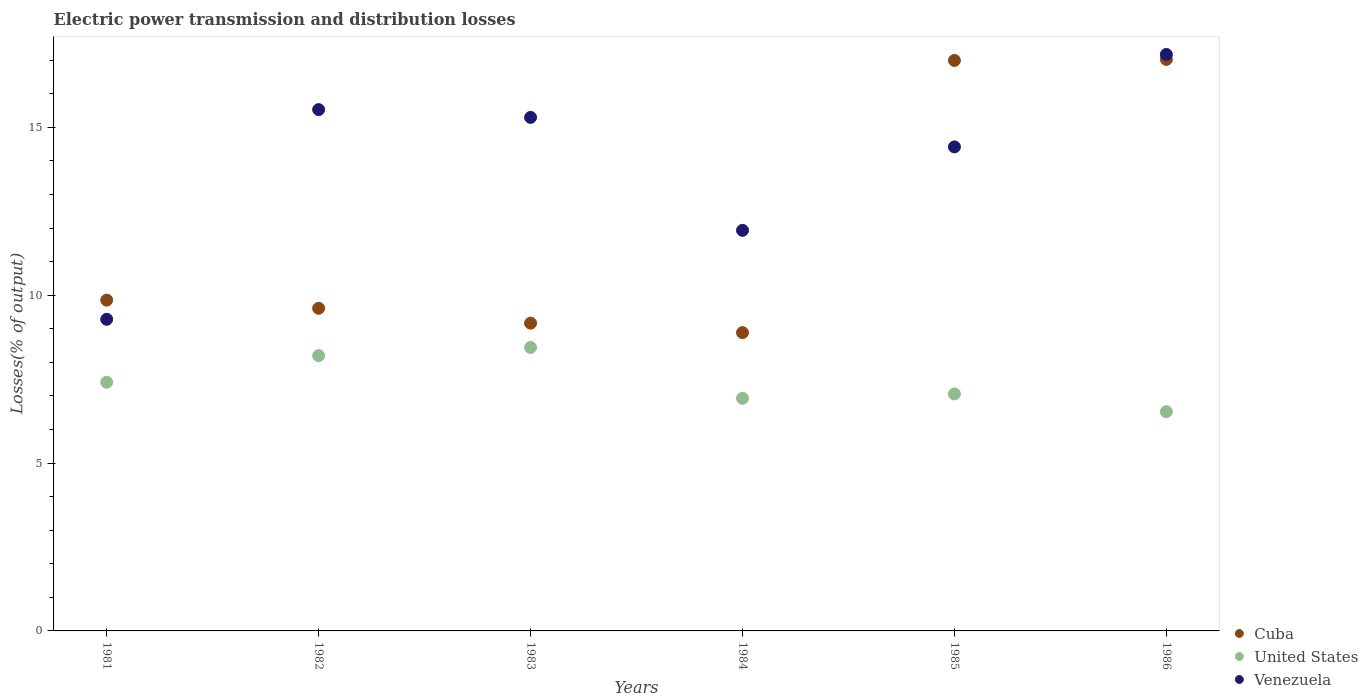How many different coloured dotlines are there?
Give a very brief answer. 3. Is the number of dotlines equal to the number of legend labels?
Give a very brief answer. Yes. What is the electric power transmission and distribution losses in Cuba in 1986?
Offer a terse response. 17.02. Across all years, what is the maximum electric power transmission and distribution losses in United States?
Your answer should be very brief. 8.44. Across all years, what is the minimum electric power transmission and distribution losses in Venezuela?
Your response must be concise. 9.28. In which year was the electric power transmission and distribution losses in Venezuela maximum?
Provide a succinct answer. 1986. In which year was the electric power transmission and distribution losses in Cuba minimum?
Keep it short and to the point. 1984. What is the total electric power transmission and distribution losses in Venezuela in the graph?
Give a very brief answer. 83.63. What is the difference between the electric power transmission and distribution losses in Venezuela in 1984 and that in 1986?
Give a very brief answer. -5.24. What is the difference between the electric power transmission and distribution losses in United States in 1985 and the electric power transmission and distribution losses in Venezuela in 1984?
Offer a very short reply. -4.87. What is the average electric power transmission and distribution losses in Cuba per year?
Make the answer very short. 11.92. In the year 1984, what is the difference between the electric power transmission and distribution losses in Cuba and electric power transmission and distribution losses in Venezuela?
Your answer should be very brief. -3.05. What is the ratio of the electric power transmission and distribution losses in Cuba in 1983 to that in 1984?
Your response must be concise. 1.03. Is the electric power transmission and distribution losses in Venezuela in 1983 less than that in 1986?
Offer a terse response. Yes. Is the difference between the electric power transmission and distribution losses in Cuba in 1981 and 1982 greater than the difference between the electric power transmission and distribution losses in Venezuela in 1981 and 1982?
Ensure brevity in your answer.  Yes. What is the difference between the highest and the second highest electric power transmission and distribution losses in United States?
Offer a terse response. 0.24. What is the difference between the highest and the lowest electric power transmission and distribution losses in Venezuela?
Offer a terse response. 7.89. Is the sum of the electric power transmission and distribution losses in Cuba in 1984 and 1986 greater than the maximum electric power transmission and distribution losses in United States across all years?
Ensure brevity in your answer.  Yes. Does the electric power transmission and distribution losses in Cuba monotonically increase over the years?
Your answer should be very brief. No. Is the electric power transmission and distribution losses in United States strictly greater than the electric power transmission and distribution losses in Venezuela over the years?
Provide a succinct answer. No. Is the electric power transmission and distribution losses in United States strictly less than the electric power transmission and distribution losses in Venezuela over the years?
Make the answer very short. Yes. How many dotlines are there?
Your answer should be very brief. 3. Does the graph contain grids?
Your answer should be very brief. No. Where does the legend appear in the graph?
Keep it short and to the point. Bottom right. What is the title of the graph?
Provide a short and direct response. Electric power transmission and distribution losses. Does "Arab World" appear as one of the legend labels in the graph?
Offer a terse response. No. What is the label or title of the Y-axis?
Give a very brief answer. Losses(% of output). What is the Losses(% of output) in Cuba in 1981?
Keep it short and to the point. 9.85. What is the Losses(% of output) of United States in 1981?
Give a very brief answer. 7.41. What is the Losses(% of output) of Venezuela in 1981?
Ensure brevity in your answer.  9.28. What is the Losses(% of output) of Cuba in 1982?
Give a very brief answer. 9.61. What is the Losses(% of output) in United States in 1982?
Your response must be concise. 8.2. What is the Losses(% of output) of Venezuela in 1982?
Offer a terse response. 15.53. What is the Losses(% of output) of Cuba in 1983?
Make the answer very short. 9.17. What is the Losses(% of output) in United States in 1983?
Offer a very short reply. 8.44. What is the Losses(% of output) of Venezuela in 1983?
Offer a very short reply. 15.3. What is the Losses(% of output) in Cuba in 1984?
Provide a succinct answer. 8.88. What is the Losses(% of output) in United States in 1984?
Your response must be concise. 6.93. What is the Losses(% of output) of Venezuela in 1984?
Provide a short and direct response. 11.93. What is the Losses(% of output) in Cuba in 1985?
Offer a terse response. 16.99. What is the Losses(% of output) in United States in 1985?
Offer a terse response. 7.06. What is the Losses(% of output) in Venezuela in 1985?
Offer a very short reply. 14.42. What is the Losses(% of output) of Cuba in 1986?
Keep it short and to the point. 17.02. What is the Losses(% of output) in United States in 1986?
Keep it short and to the point. 6.53. What is the Losses(% of output) of Venezuela in 1986?
Provide a succinct answer. 17.17. Across all years, what is the maximum Losses(% of output) in Cuba?
Make the answer very short. 17.02. Across all years, what is the maximum Losses(% of output) in United States?
Make the answer very short. 8.44. Across all years, what is the maximum Losses(% of output) of Venezuela?
Keep it short and to the point. 17.17. Across all years, what is the minimum Losses(% of output) in Cuba?
Your answer should be very brief. 8.88. Across all years, what is the minimum Losses(% of output) of United States?
Provide a short and direct response. 6.53. Across all years, what is the minimum Losses(% of output) in Venezuela?
Your response must be concise. 9.28. What is the total Losses(% of output) of Cuba in the graph?
Keep it short and to the point. 71.53. What is the total Losses(% of output) of United States in the graph?
Provide a short and direct response. 44.57. What is the total Losses(% of output) of Venezuela in the graph?
Keep it short and to the point. 83.63. What is the difference between the Losses(% of output) in Cuba in 1981 and that in 1982?
Your answer should be compact. 0.24. What is the difference between the Losses(% of output) in United States in 1981 and that in 1982?
Offer a very short reply. -0.79. What is the difference between the Losses(% of output) in Venezuela in 1981 and that in 1982?
Offer a terse response. -6.25. What is the difference between the Losses(% of output) of Cuba in 1981 and that in 1983?
Make the answer very short. 0.69. What is the difference between the Losses(% of output) of United States in 1981 and that in 1983?
Your answer should be very brief. -1.04. What is the difference between the Losses(% of output) of Venezuela in 1981 and that in 1983?
Your answer should be compact. -6.01. What is the difference between the Losses(% of output) in Cuba in 1981 and that in 1984?
Give a very brief answer. 0.97. What is the difference between the Losses(% of output) of United States in 1981 and that in 1984?
Your response must be concise. 0.48. What is the difference between the Losses(% of output) of Venezuela in 1981 and that in 1984?
Provide a succinct answer. -2.65. What is the difference between the Losses(% of output) of Cuba in 1981 and that in 1985?
Make the answer very short. -7.14. What is the difference between the Losses(% of output) in United States in 1981 and that in 1985?
Your answer should be very brief. 0.35. What is the difference between the Losses(% of output) in Venezuela in 1981 and that in 1985?
Your answer should be compact. -5.13. What is the difference between the Losses(% of output) in Cuba in 1981 and that in 1986?
Make the answer very short. -7.17. What is the difference between the Losses(% of output) of United States in 1981 and that in 1986?
Your answer should be compact. 0.88. What is the difference between the Losses(% of output) in Venezuela in 1981 and that in 1986?
Give a very brief answer. -7.89. What is the difference between the Losses(% of output) of Cuba in 1982 and that in 1983?
Give a very brief answer. 0.44. What is the difference between the Losses(% of output) in United States in 1982 and that in 1983?
Give a very brief answer. -0.24. What is the difference between the Losses(% of output) of Venezuela in 1982 and that in 1983?
Make the answer very short. 0.23. What is the difference between the Losses(% of output) of Cuba in 1982 and that in 1984?
Offer a terse response. 0.73. What is the difference between the Losses(% of output) of United States in 1982 and that in 1984?
Your answer should be compact. 1.27. What is the difference between the Losses(% of output) of Venezuela in 1982 and that in 1984?
Ensure brevity in your answer.  3.6. What is the difference between the Losses(% of output) of Cuba in 1982 and that in 1985?
Make the answer very short. -7.38. What is the difference between the Losses(% of output) of United States in 1982 and that in 1985?
Your answer should be very brief. 1.14. What is the difference between the Losses(% of output) of Venezuela in 1982 and that in 1985?
Offer a very short reply. 1.11. What is the difference between the Losses(% of output) in Cuba in 1982 and that in 1986?
Offer a very short reply. -7.41. What is the difference between the Losses(% of output) of United States in 1982 and that in 1986?
Keep it short and to the point. 1.67. What is the difference between the Losses(% of output) in Venezuela in 1982 and that in 1986?
Ensure brevity in your answer.  -1.64. What is the difference between the Losses(% of output) in Cuba in 1983 and that in 1984?
Provide a short and direct response. 0.28. What is the difference between the Losses(% of output) in United States in 1983 and that in 1984?
Your response must be concise. 1.51. What is the difference between the Losses(% of output) of Venezuela in 1983 and that in 1984?
Offer a terse response. 3.36. What is the difference between the Losses(% of output) in Cuba in 1983 and that in 1985?
Offer a very short reply. -7.83. What is the difference between the Losses(% of output) in United States in 1983 and that in 1985?
Provide a short and direct response. 1.38. What is the difference between the Losses(% of output) of Venezuela in 1983 and that in 1985?
Keep it short and to the point. 0.88. What is the difference between the Losses(% of output) in Cuba in 1983 and that in 1986?
Give a very brief answer. -7.86. What is the difference between the Losses(% of output) of United States in 1983 and that in 1986?
Make the answer very short. 1.91. What is the difference between the Losses(% of output) of Venezuela in 1983 and that in 1986?
Ensure brevity in your answer.  -1.87. What is the difference between the Losses(% of output) of Cuba in 1984 and that in 1985?
Make the answer very short. -8.11. What is the difference between the Losses(% of output) in United States in 1984 and that in 1985?
Provide a succinct answer. -0.13. What is the difference between the Losses(% of output) of Venezuela in 1984 and that in 1985?
Your answer should be compact. -2.49. What is the difference between the Losses(% of output) of Cuba in 1984 and that in 1986?
Ensure brevity in your answer.  -8.14. What is the difference between the Losses(% of output) in United States in 1984 and that in 1986?
Keep it short and to the point. 0.4. What is the difference between the Losses(% of output) in Venezuela in 1984 and that in 1986?
Provide a short and direct response. -5.24. What is the difference between the Losses(% of output) of Cuba in 1985 and that in 1986?
Your response must be concise. -0.03. What is the difference between the Losses(% of output) of United States in 1985 and that in 1986?
Provide a succinct answer. 0.53. What is the difference between the Losses(% of output) in Venezuela in 1985 and that in 1986?
Offer a terse response. -2.75. What is the difference between the Losses(% of output) of Cuba in 1981 and the Losses(% of output) of United States in 1982?
Provide a succinct answer. 1.66. What is the difference between the Losses(% of output) of Cuba in 1981 and the Losses(% of output) of Venezuela in 1982?
Provide a short and direct response. -5.67. What is the difference between the Losses(% of output) of United States in 1981 and the Losses(% of output) of Venezuela in 1982?
Provide a succinct answer. -8.12. What is the difference between the Losses(% of output) of Cuba in 1981 and the Losses(% of output) of United States in 1983?
Offer a terse response. 1.41. What is the difference between the Losses(% of output) of Cuba in 1981 and the Losses(% of output) of Venezuela in 1983?
Keep it short and to the point. -5.44. What is the difference between the Losses(% of output) in United States in 1981 and the Losses(% of output) in Venezuela in 1983?
Offer a terse response. -7.89. What is the difference between the Losses(% of output) of Cuba in 1981 and the Losses(% of output) of United States in 1984?
Ensure brevity in your answer.  2.92. What is the difference between the Losses(% of output) in Cuba in 1981 and the Losses(% of output) in Venezuela in 1984?
Offer a very short reply. -2.08. What is the difference between the Losses(% of output) in United States in 1981 and the Losses(% of output) in Venezuela in 1984?
Provide a short and direct response. -4.52. What is the difference between the Losses(% of output) in Cuba in 1981 and the Losses(% of output) in United States in 1985?
Give a very brief answer. 2.79. What is the difference between the Losses(% of output) of Cuba in 1981 and the Losses(% of output) of Venezuela in 1985?
Offer a very short reply. -4.56. What is the difference between the Losses(% of output) in United States in 1981 and the Losses(% of output) in Venezuela in 1985?
Your answer should be very brief. -7.01. What is the difference between the Losses(% of output) of Cuba in 1981 and the Losses(% of output) of United States in 1986?
Make the answer very short. 3.32. What is the difference between the Losses(% of output) of Cuba in 1981 and the Losses(% of output) of Venezuela in 1986?
Provide a succinct answer. -7.32. What is the difference between the Losses(% of output) of United States in 1981 and the Losses(% of output) of Venezuela in 1986?
Give a very brief answer. -9.76. What is the difference between the Losses(% of output) in Cuba in 1982 and the Losses(% of output) in United States in 1983?
Make the answer very short. 1.17. What is the difference between the Losses(% of output) of Cuba in 1982 and the Losses(% of output) of Venezuela in 1983?
Provide a short and direct response. -5.69. What is the difference between the Losses(% of output) of United States in 1982 and the Losses(% of output) of Venezuela in 1983?
Offer a terse response. -7.1. What is the difference between the Losses(% of output) in Cuba in 1982 and the Losses(% of output) in United States in 1984?
Your answer should be very brief. 2.68. What is the difference between the Losses(% of output) in Cuba in 1982 and the Losses(% of output) in Venezuela in 1984?
Give a very brief answer. -2.32. What is the difference between the Losses(% of output) in United States in 1982 and the Losses(% of output) in Venezuela in 1984?
Keep it short and to the point. -3.73. What is the difference between the Losses(% of output) of Cuba in 1982 and the Losses(% of output) of United States in 1985?
Your answer should be very brief. 2.55. What is the difference between the Losses(% of output) of Cuba in 1982 and the Losses(% of output) of Venezuela in 1985?
Give a very brief answer. -4.81. What is the difference between the Losses(% of output) of United States in 1982 and the Losses(% of output) of Venezuela in 1985?
Your answer should be very brief. -6.22. What is the difference between the Losses(% of output) of Cuba in 1982 and the Losses(% of output) of United States in 1986?
Ensure brevity in your answer.  3.08. What is the difference between the Losses(% of output) in Cuba in 1982 and the Losses(% of output) in Venezuela in 1986?
Keep it short and to the point. -7.56. What is the difference between the Losses(% of output) of United States in 1982 and the Losses(% of output) of Venezuela in 1986?
Ensure brevity in your answer.  -8.97. What is the difference between the Losses(% of output) of Cuba in 1983 and the Losses(% of output) of United States in 1984?
Make the answer very short. 2.24. What is the difference between the Losses(% of output) of Cuba in 1983 and the Losses(% of output) of Venezuela in 1984?
Keep it short and to the point. -2.76. What is the difference between the Losses(% of output) of United States in 1983 and the Losses(% of output) of Venezuela in 1984?
Ensure brevity in your answer.  -3.49. What is the difference between the Losses(% of output) of Cuba in 1983 and the Losses(% of output) of United States in 1985?
Offer a terse response. 2.11. What is the difference between the Losses(% of output) in Cuba in 1983 and the Losses(% of output) in Venezuela in 1985?
Ensure brevity in your answer.  -5.25. What is the difference between the Losses(% of output) of United States in 1983 and the Losses(% of output) of Venezuela in 1985?
Your response must be concise. -5.97. What is the difference between the Losses(% of output) in Cuba in 1983 and the Losses(% of output) in United States in 1986?
Ensure brevity in your answer.  2.64. What is the difference between the Losses(% of output) of Cuba in 1983 and the Losses(% of output) of Venezuela in 1986?
Your response must be concise. -8. What is the difference between the Losses(% of output) in United States in 1983 and the Losses(% of output) in Venezuela in 1986?
Make the answer very short. -8.73. What is the difference between the Losses(% of output) in Cuba in 1984 and the Losses(% of output) in United States in 1985?
Offer a very short reply. 1.83. What is the difference between the Losses(% of output) in Cuba in 1984 and the Losses(% of output) in Venezuela in 1985?
Ensure brevity in your answer.  -5.53. What is the difference between the Losses(% of output) in United States in 1984 and the Losses(% of output) in Venezuela in 1985?
Make the answer very short. -7.49. What is the difference between the Losses(% of output) of Cuba in 1984 and the Losses(% of output) of United States in 1986?
Your answer should be very brief. 2.35. What is the difference between the Losses(% of output) in Cuba in 1984 and the Losses(% of output) in Venezuela in 1986?
Make the answer very short. -8.29. What is the difference between the Losses(% of output) in United States in 1984 and the Losses(% of output) in Venezuela in 1986?
Your response must be concise. -10.24. What is the difference between the Losses(% of output) of Cuba in 1985 and the Losses(% of output) of United States in 1986?
Your answer should be very brief. 10.46. What is the difference between the Losses(% of output) in Cuba in 1985 and the Losses(% of output) in Venezuela in 1986?
Keep it short and to the point. -0.18. What is the difference between the Losses(% of output) of United States in 1985 and the Losses(% of output) of Venezuela in 1986?
Your answer should be compact. -10.11. What is the average Losses(% of output) of Cuba per year?
Offer a terse response. 11.92. What is the average Losses(% of output) of United States per year?
Provide a succinct answer. 7.43. What is the average Losses(% of output) of Venezuela per year?
Your answer should be very brief. 13.94. In the year 1981, what is the difference between the Losses(% of output) in Cuba and Losses(% of output) in United States?
Provide a short and direct response. 2.45. In the year 1981, what is the difference between the Losses(% of output) in Cuba and Losses(% of output) in Venezuela?
Offer a very short reply. 0.57. In the year 1981, what is the difference between the Losses(% of output) in United States and Losses(% of output) in Venezuela?
Ensure brevity in your answer.  -1.88. In the year 1982, what is the difference between the Losses(% of output) of Cuba and Losses(% of output) of United States?
Provide a succinct answer. 1.41. In the year 1982, what is the difference between the Losses(% of output) in Cuba and Losses(% of output) in Venezuela?
Provide a succinct answer. -5.92. In the year 1982, what is the difference between the Losses(% of output) in United States and Losses(% of output) in Venezuela?
Provide a succinct answer. -7.33. In the year 1983, what is the difference between the Losses(% of output) in Cuba and Losses(% of output) in United States?
Offer a terse response. 0.72. In the year 1983, what is the difference between the Losses(% of output) of Cuba and Losses(% of output) of Venezuela?
Provide a succinct answer. -6.13. In the year 1983, what is the difference between the Losses(% of output) of United States and Losses(% of output) of Venezuela?
Offer a terse response. -6.85. In the year 1984, what is the difference between the Losses(% of output) in Cuba and Losses(% of output) in United States?
Your answer should be compact. 1.95. In the year 1984, what is the difference between the Losses(% of output) of Cuba and Losses(% of output) of Venezuela?
Ensure brevity in your answer.  -3.05. In the year 1984, what is the difference between the Losses(% of output) of United States and Losses(% of output) of Venezuela?
Make the answer very short. -5. In the year 1985, what is the difference between the Losses(% of output) in Cuba and Losses(% of output) in United States?
Offer a terse response. 9.93. In the year 1985, what is the difference between the Losses(% of output) of Cuba and Losses(% of output) of Venezuela?
Provide a succinct answer. 2.58. In the year 1985, what is the difference between the Losses(% of output) in United States and Losses(% of output) in Venezuela?
Your answer should be very brief. -7.36. In the year 1986, what is the difference between the Losses(% of output) in Cuba and Losses(% of output) in United States?
Ensure brevity in your answer.  10.49. In the year 1986, what is the difference between the Losses(% of output) of Cuba and Losses(% of output) of Venezuela?
Ensure brevity in your answer.  -0.15. In the year 1986, what is the difference between the Losses(% of output) of United States and Losses(% of output) of Venezuela?
Offer a very short reply. -10.64. What is the ratio of the Losses(% of output) in Cuba in 1981 to that in 1982?
Your answer should be compact. 1.03. What is the ratio of the Losses(% of output) in United States in 1981 to that in 1982?
Your answer should be compact. 0.9. What is the ratio of the Losses(% of output) of Venezuela in 1981 to that in 1982?
Make the answer very short. 0.6. What is the ratio of the Losses(% of output) of Cuba in 1981 to that in 1983?
Provide a short and direct response. 1.07. What is the ratio of the Losses(% of output) in United States in 1981 to that in 1983?
Ensure brevity in your answer.  0.88. What is the ratio of the Losses(% of output) of Venezuela in 1981 to that in 1983?
Your response must be concise. 0.61. What is the ratio of the Losses(% of output) of Cuba in 1981 to that in 1984?
Your answer should be compact. 1.11. What is the ratio of the Losses(% of output) in United States in 1981 to that in 1984?
Give a very brief answer. 1.07. What is the ratio of the Losses(% of output) in Venezuela in 1981 to that in 1984?
Offer a terse response. 0.78. What is the ratio of the Losses(% of output) of Cuba in 1981 to that in 1985?
Provide a short and direct response. 0.58. What is the ratio of the Losses(% of output) in United States in 1981 to that in 1985?
Make the answer very short. 1.05. What is the ratio of the Losses(% of output) in Venezuela in 1981 to that in 1985?
Keep it short and to the point. 0.64. What is the ratio of the Losses(% of output) in Cuba in 1981 to that in 1986?
Give a very brief answer. 0.58. What is the ratio of the Losses(% of output) of United States in 1981 to that in 1986?
Provide a short and direct response. 1.13. What is the ratio of the Losses(% of output) in Venezuela in 1981 to that in 1986?
Provide a short and direct response. 0.54. What is the ratio of the Losses(% of output) in Cuba in 1982 to that in 1983?
Give a very brief answer. 1.05. What is the ratio of the Losses(% of output) of United States in 1982 to that in 1983?
Make the answer very short. 0.97. What is the ratio of the Losses(% of output) in Venezuela in 1982 to that in 1983?
Offer a terse response. 1.02. What is the ratio of the Losses(% of output) in Cuba in 1982 to that in 1984?
Make the answer very short. 1.08. What is the ratio of the Losses(% of output) in United States in 1982 to that in 1984?
Provide a succinct answer. 1.18. What is the ratio of the Losses(% of output) in Venezuela in 1982 to that in 1984?
Make the answer very short. 1.3. What is the ratio of the Losses(% of output) of Cuba in 1982 to that in 1985?
Ensure brevity in your answer.  0.57. What is the ratio of the Losses(% of output) of United States in 1982 to that in 1985?
Your response must be concise. 1.16. What is the ratio of the Losses(% of output) in Venezuela in 1982 to that in 1985?
Give a very brief answer. 1.08. What is the ratio of the Losses(% of output) in Cuba in 1982 to that in 1986?
Provide a short and direct response. 0.56. What is the ratio of the Losses(% of output) in United States in 1982 to that in 1986?
Make the answer very short. 1.26. What is the ratio of the Losses(% of output) of Venezuela in 1982 to that in 1986?
Make the answer very short. 0.9. What is the ratio of the Losses(% of output) of Cuba in 1983 to that in 1984?
Provide a short and direct response. 1.03. What is the ratio of the Losses(% of output) in United States in 1983 to that in 1984?
Your answer should be very brief. 1.22. What is the ratio of the Losses(% of output) of Venezuela in 1983 to that in 1984?
Make the answer very short. 1.28. What is the ratio of the Losses(% of output) in Cuba in 1983 to that in 1985?
Offer a very short reply. 0.54. What is the ratio of the Losses(% of output) in United States in 1983 to that in 1985?
Your answer should be very brief. 1.2. What is the ratio of the Losses(% of output) of Venezuela in 1983 to that in 1985?
Provide a short and direct response. 1.06. What is the ratio of the Losses(% of output) of Cuba in 1983 to that in 1986?
Your response must be concise. 0.54. What is the ratio of the Losses(% of output) in United States in 1983 to that in 1986?
Your response must be concise. 1.29. What is the ratio of the Losses(% of output) in Venezuela in 1983 to that in 1986?
Make the answer very short. 0.89. What is the ratio of the Losses(% of output) of Cuba in 1984 to that in 1985?
Provide a short and direct response. 0.52. What is the ratio of the Losses(% of output) in United States in 1984 to that in 1985?
Give a very brief answer. 0.98. What is the ratio of the Losses(% of output) of Venezuela in 1984 to that in 1985?
Your response must be concise. 0.83. What is the ratio of the Losses(% of output) in Cuba in 1984 to that in 1986?
Your response must be concise. 0.52. What is the ratio of the Losses(% of output) of United States in 1984 to that in 1986?
Your answer should be very brief. 1.06. What is the ratio of the Losses(% of output) in Venezuela in 1984 to that in 1986?
Ensure brevity in your answer.  0.69. What is the ratio of the Losses(% of output) of United States in 1985 to that in 1986?
Provide a succinct answer. 1.08. What is the ratio of the Losses(% of output) in Venezuela in 1985 to that in 1986?
Provide a short and direct response. 0.84. What is the difference between the highest and the second highest Losses(% of output) in Cuba?
Give a very brief answer. 0.03. What is the difference between the highest and the second highest Losses(% of output) in United States?
Keep it short and to the point. 0.24. What is the difference between the highest and the second highest Losses(% of output) in Venezuela?
Keep it short and to the point. 1.64. What is the difference between the highest and the lowest Losses(% of output) of Cuba?
Offer a very short reply. 8.14. What is the difference between the highest and the lowest Losses(% of output) in United States?
Provide a short and direct response. 1.91. What is the difference between the highest and the lowest Losses(% of output) of Venezuela?
Your response must be concise. 7.89. 